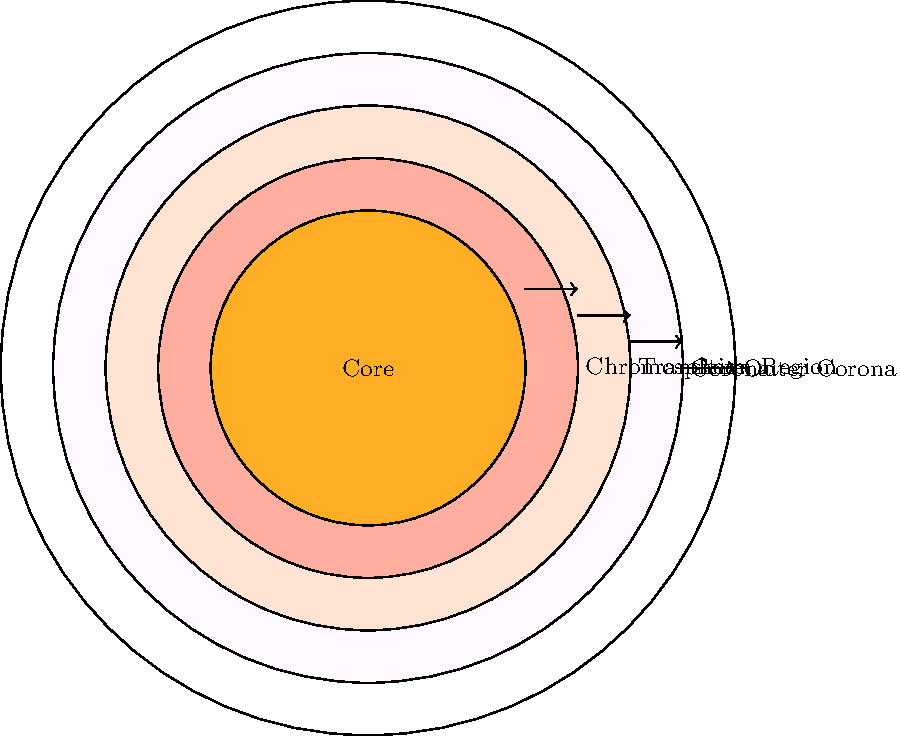As a photography enthusiast, you're planning a series of shots to capture the Sun's layers during a solar eclipse. Which layer of the Sun's atmosphere, known for its reddish color and visible during total solar eclipses, would be your primary focus for creating a visually striking image that Gordon Parks might appreciate? To answer this question, let's break down the layers of the Sun's atmosphere as shown in the diagram:

1. Core: This is the innermost part of the Sun, not visible from Earth.
2. Chromosphere: This is the first layer of the Sun's atmosphere, just above the visible surface (photosphere, not labeled in the diagram). It has a reddish color.
3. Transition Region: A thin layer between the chromosphere and corona.
4. Corona: The outermost layer of the Sun's atmosphere, extending far into space.
5. Outer Corona: The furthest reaches of the corona.

The key points to consider are:
- The question asks about a layer visible during total solar eclipses.
- It mentions a reddish color.
- The layer should be visually striking for photography.

The chromosphere fits all these criteria:
- It's visible during total solar eclipses when the Moon blocks the bright photosphere.
- It has a distinct reddish color, as mentioned in the question.
- Its color and visibility during eclipses make it a prime subject for dramatic photography.

Gordon Parks, known for his impactful and often colorful photography, would likely appreciate the visual drama of the chromosphere during an eclipse.
Answer: Chromosphere 